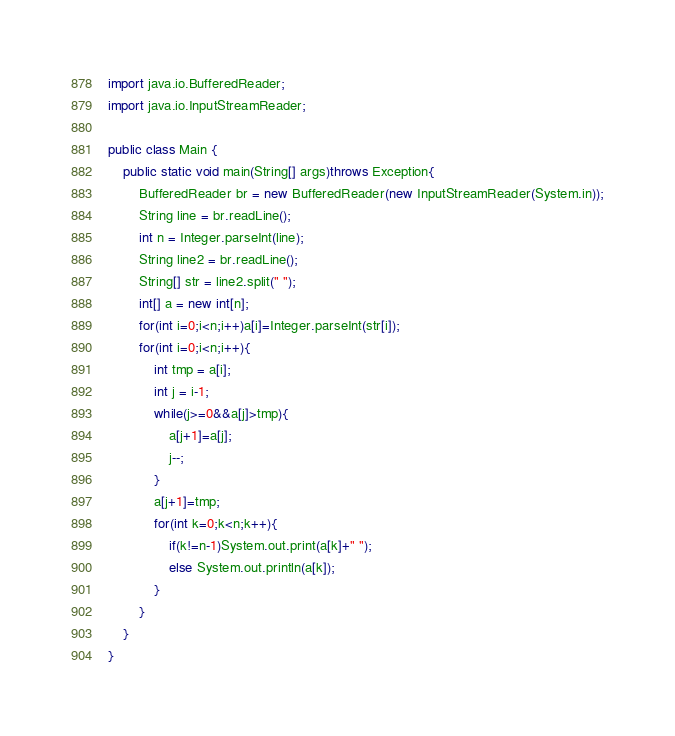Convert code to text. <code><loc_0><loc_0><loc_500><loc_500><_Java_>import java.io.BufferedReader;
import java.io.InputStreamReader;

public class Main {
	public static void main(String[] args)throws Exception{
        BufferedReader br = new BufferedReader(new InputStreamReader(System.in));
        String line = br.readLine();
        int n = Integer.parseInt(line);
        String line2 = br.readLine();
        String[] str = line2.split(" ");
        int[] a = new int[n];
        for(int i=0;i<n;i++)a[i]=Integer.parseInt(str[i]);
        for(int i=0;i<n;i++){
        	int tmp = a[i];
        	int j = i-1;
        	while(j>=0&&a[j]>tmp){
        		a[j+1]=a[j];
        		j--;
        	}
        	a[j+1]=tmp;
        	for(int k=0;k<n;k++){
        		if(k!=n-1)System.out.print(a[k]+" ");
        		else System.out.println(a[k]);
        	}
        }
	}
}</code> 